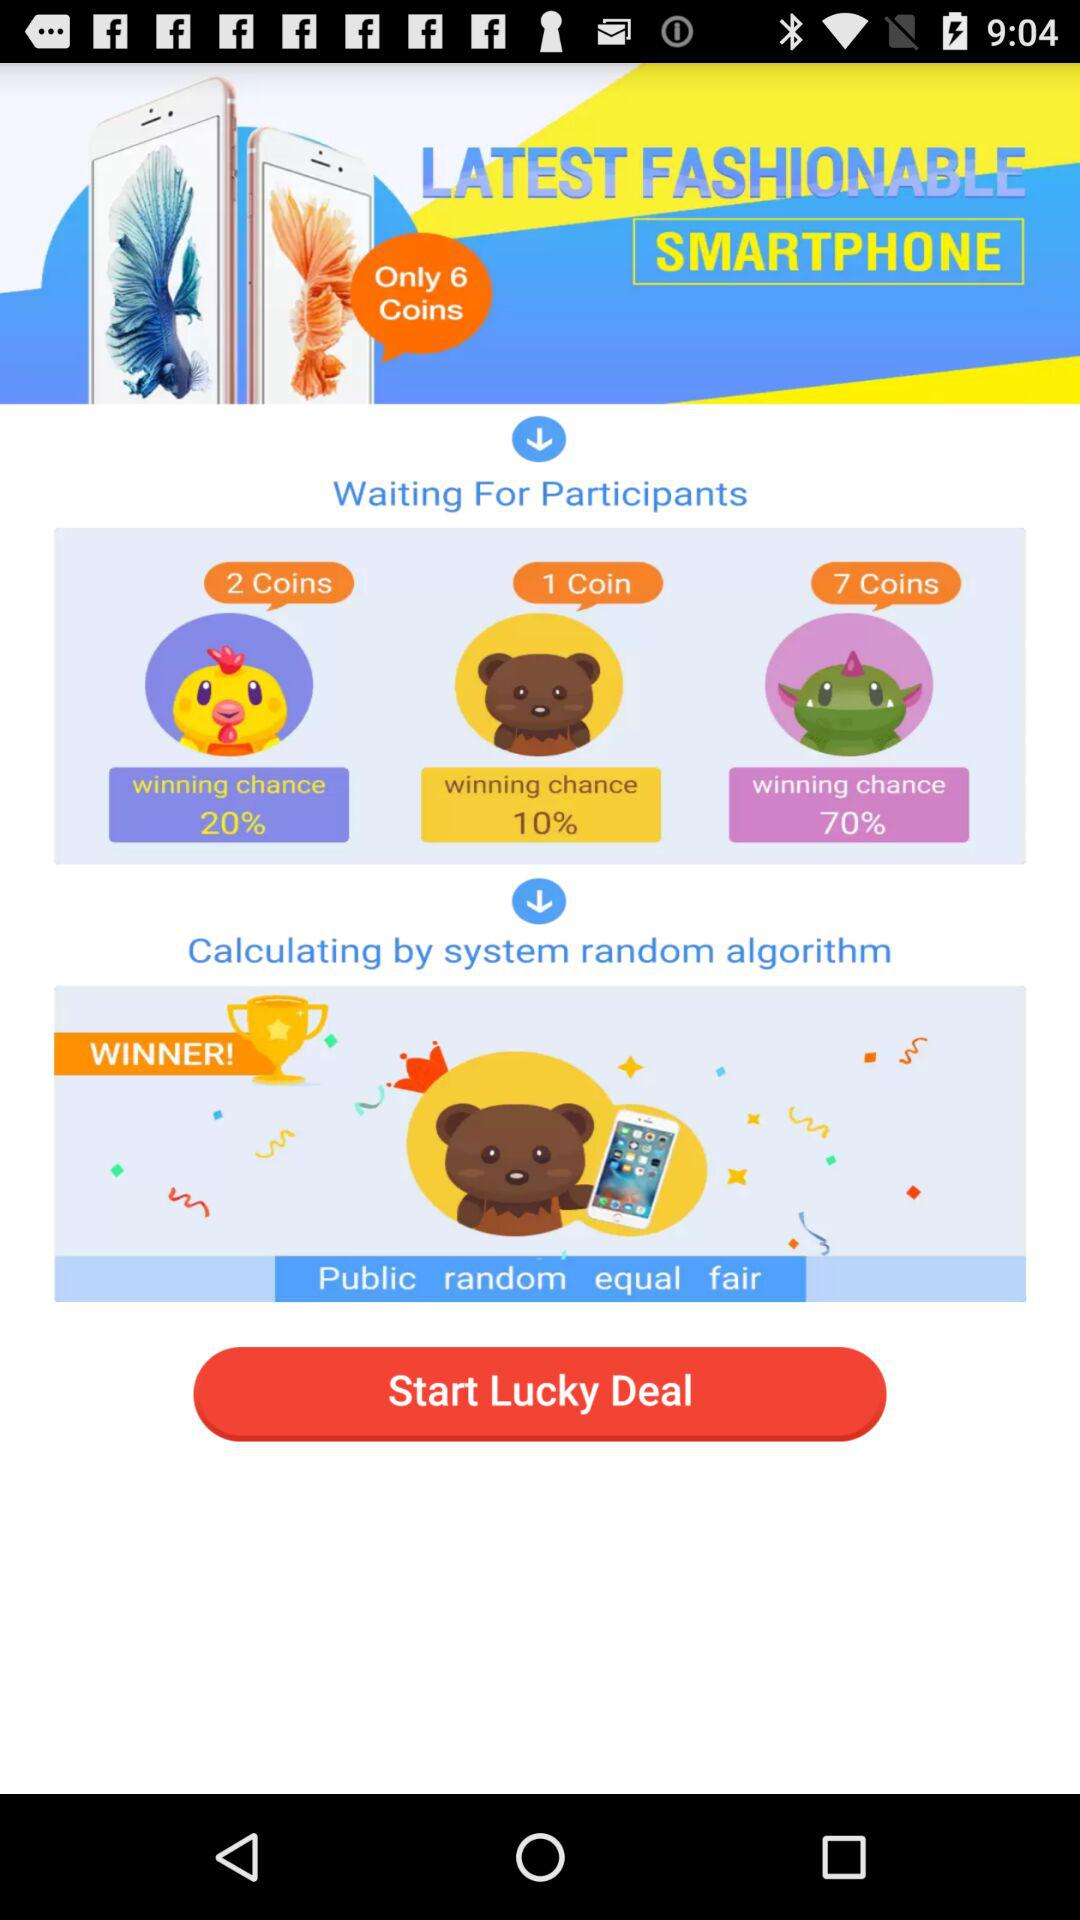How many coins can you win on Teddy Emojis? The number of coins you can win is 1. 